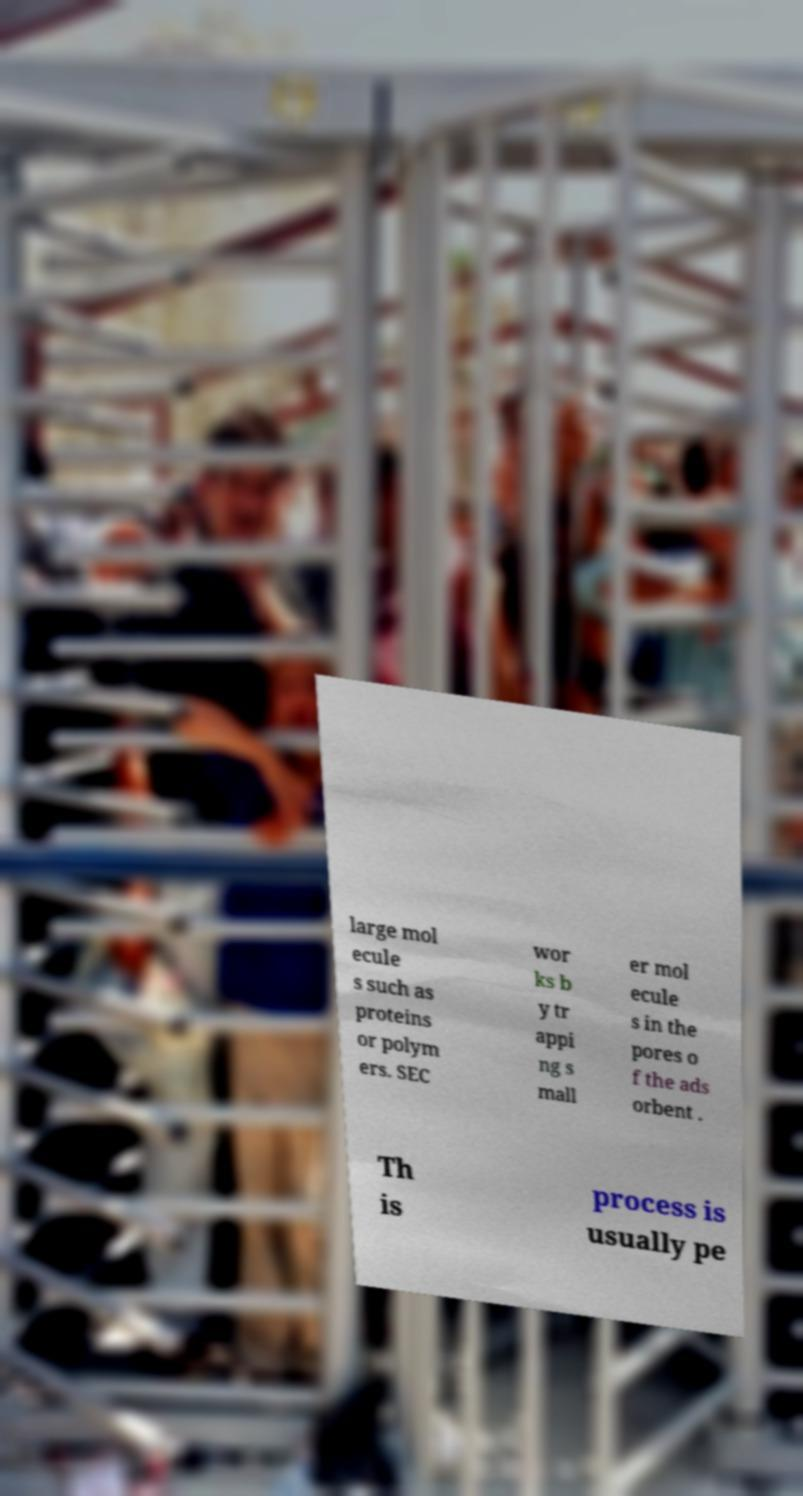Please read and relay the text visible in this image. What does it say? large mol ecule s such as proteins or polym ers. SEC wor ks b y tr appi ng s mall er mol ecule s in the pores o f the ads orbent . Th is process is usually pe 